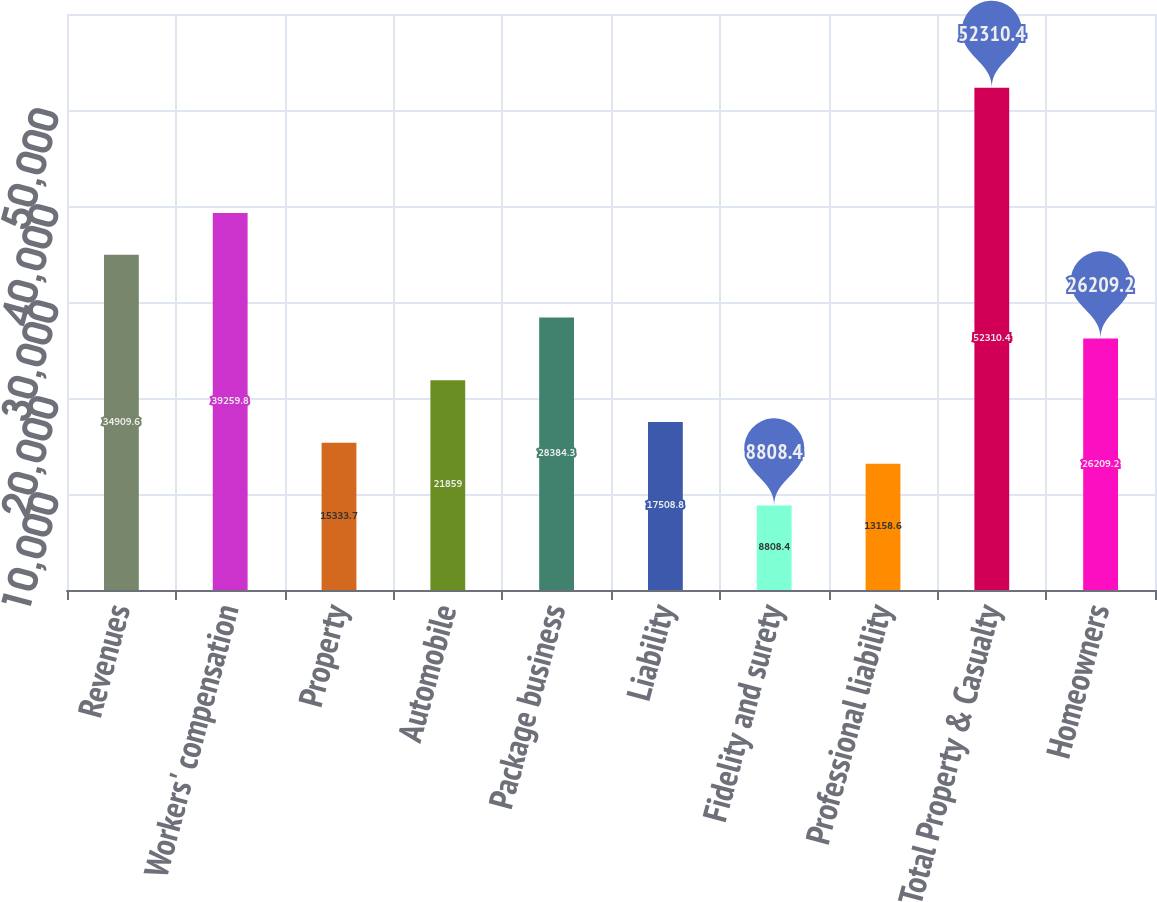<chart> <loc_0><loc_0><loc_500><loc_500><bar_chart><fcel>Revenues<fcel>Workers' compensation<fcel>Property<fcel>Automobile<fcel>Package business<fcel>Liability<fcel>Fidelity and surety<fcel>Professional liability<fcel>Total Property & Casualty<fcel>Homeowners<nl><fcel>34909.6<fcel>39259.8<fcel>15333.7<fcel>21859<fcel>28384.3<fcel>17508.8<fcel>8808.4<fcel>13158.6<fcel>52310.4<fcel>26209.2<nl></chart> 